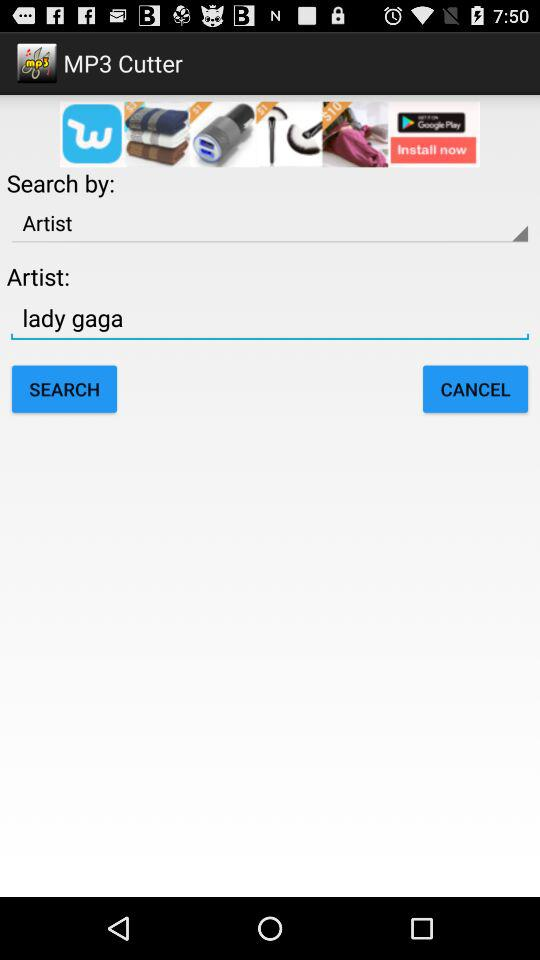What is the app name? The app name is "MP3 Cutter". 